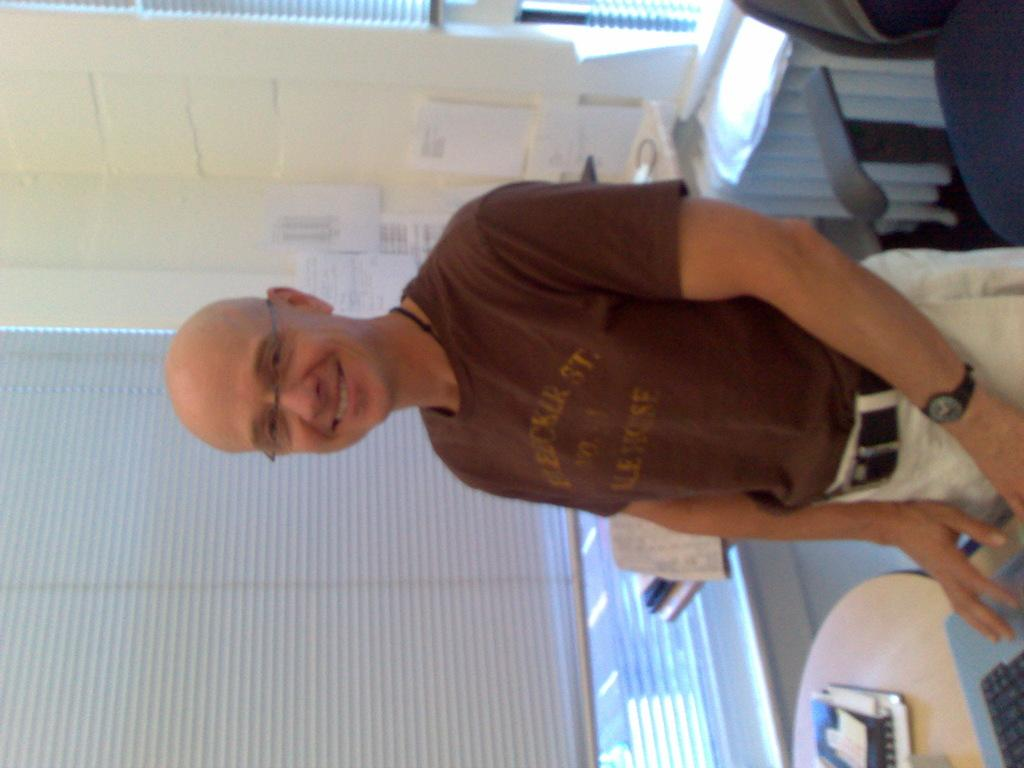What is the person in the image doing? The person is standing and smiling in the image. What objects are on the table in the image? There is a laptop and a book on the table. What can be seen in the background of the image? There is a chair, a window shutter, and papers stick to the wall in the background of the image. Can you see any kitty or jellyfish in the image? No, there are no kitties or jellyfish present in the image. 